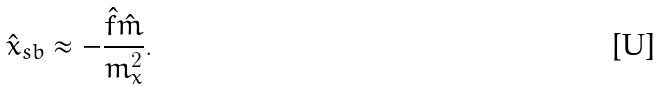Convert formula to latex. <formula><loc_0><loc_0><loc_500><loc_500>\hat { x } _ { s b } \approx - \frac { \hat { f } \hat { m } } { m _ { x } ^ { 2 } } .</formula> 